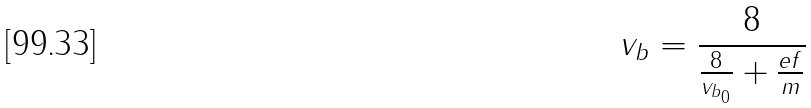Convert formula to latex. <formula><loc_0><loc_0><loc_500><loc_500>v _ { b } = \frac { 8 } { \frac { 8 } { v _ { b _ { 0 } } } + \frac { e f } { m } }</formula> 